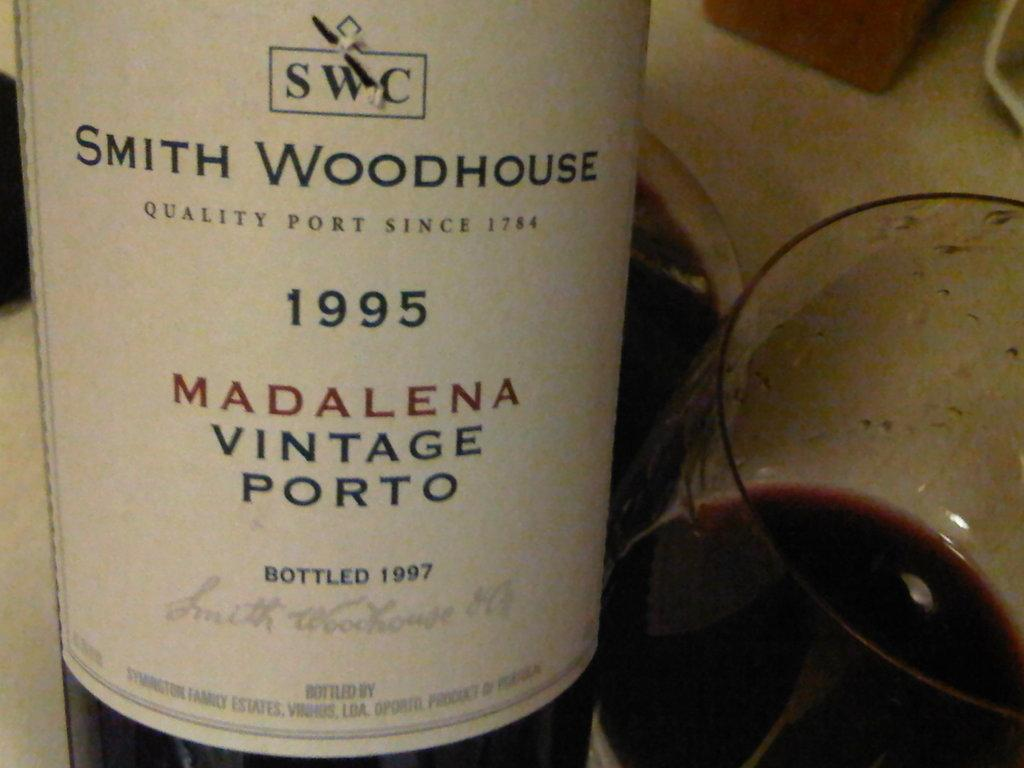Provide a one-sentence caption for the provided image. A glass of wine alongside the bottle of Smith Woodhouse Madalena Vintage Porto, from 1995. 